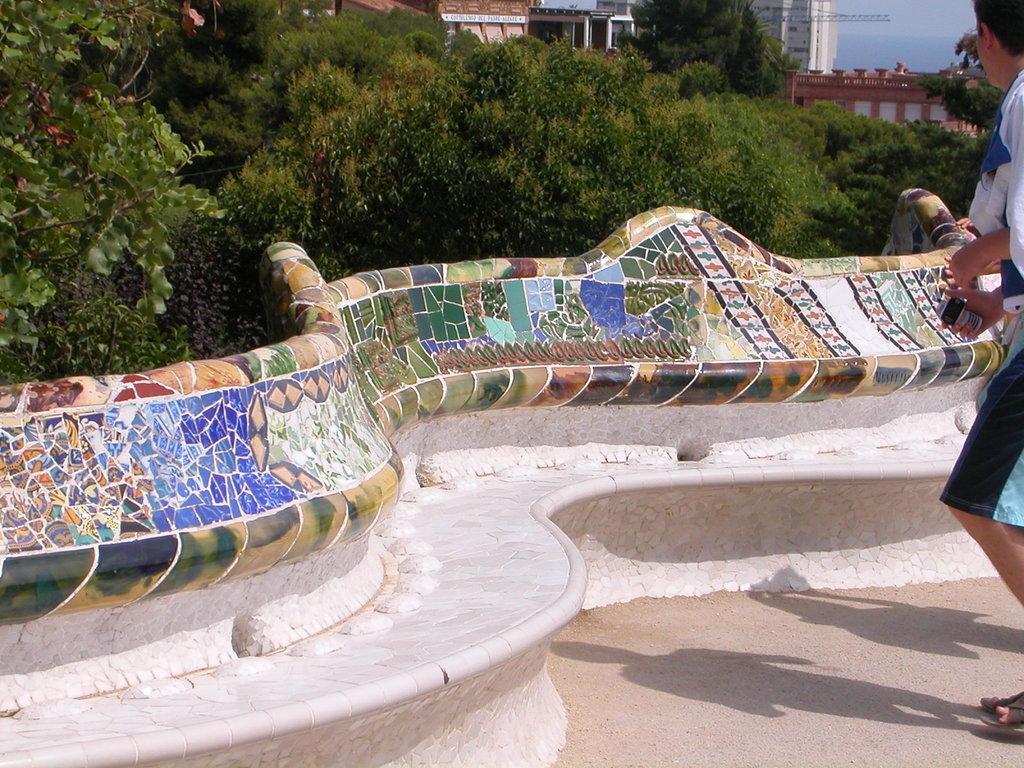Can you describe this image briefly? In this image I can see few trees, buildings, few people and the colorful wall. 